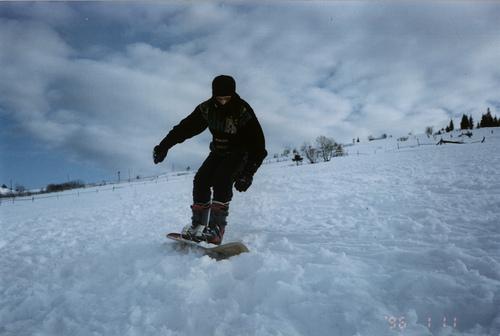Is he bundled up?
Give a very brief answer. Yes. What color clothes is he wearing?
Quick response, please. Black. Is he on a snowboard?
Concise answer only. Yes. 